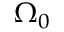Convert formula to latex. <formula><loc_0><loc_0><loc_500><loc_500>\Omega _ { 0 }</formula> 